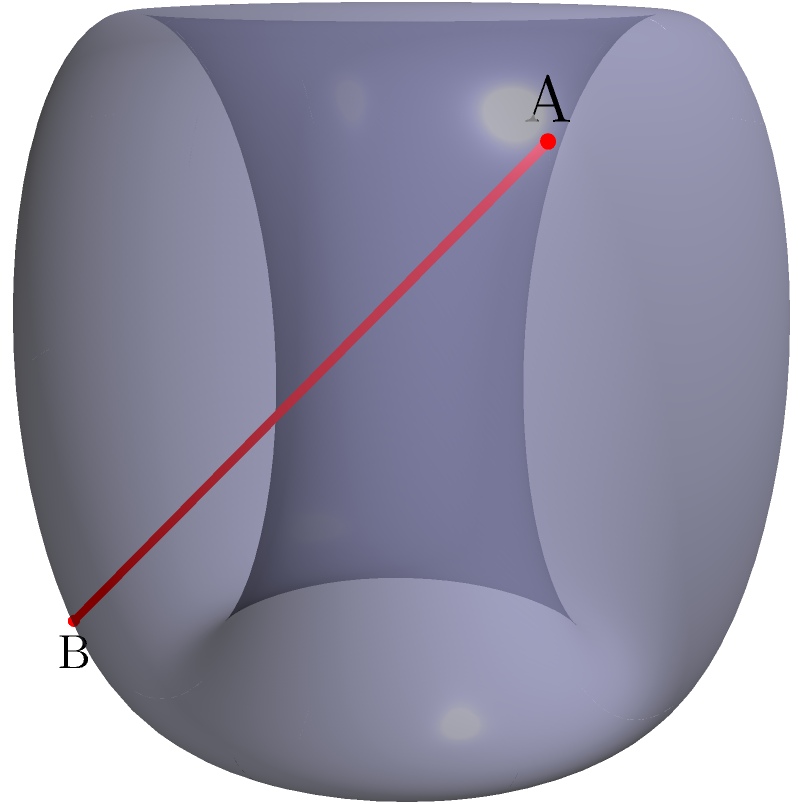In jiu-jitsu, understanding the shortest path between two points on a curved surface can be crucial for efficient movement. Consider a torus with major radius $R=2$ and minor radius $r=1$. Two points, A and B, are located at $(π/4, π/4)$ and $(7π/4, 7π/4)$ respectively in the torus's parametric coordinates $(θ, φ)$. What is the approximate length of the shortest path (geodesic) between A and B on the surface of the torus? To solve this problem, we'll follow these steps:

1) The parametric equations for a torus are:
   $x = (R + r\cos φ)\cos θ$
   $y = (R + r\cos φ)\sin θ$
   $z = r\sin φ$

2) The geodesic on a torus is not always a straight line in the 3D space. However, for this specific case, the shortest path is close to a straight line.

3) To calculate the approximate length, we'll use the straight-line distance as an estimation:

   a) Convert the parametric coordinates to Cartesian:
      A: $(2.54, 1.05, 0.71)$
      B: $(-2.54, -1.05, -0.71)$

   b) Calculate the distance using the 3D distance formula:
      $d = \sqrt{(x_2-x_1)^2 + (y_2-y_1)^2 + (z_2-z_1)^2}$

   c) Plugging in the values:
      $d = \sqrt{(-2.54-2.54)^2 + (-1.05-1.05)^2 + (-0.71-0.71)^2}$
      $d = \sqrt{(-5.08)^2 + (-2.1)^2 + (-1.42)^2}$
      $d = \sqrt{25.8064 + 4.41 + 2.0164}$
      $d = \sqrt{32.2328}$
      $d ≈ 5.68$

4) This straight-line distance is an underestimation of the true geodesic length, but it provides a good approximation for this case.
Answer: Approximately 5.68 units 